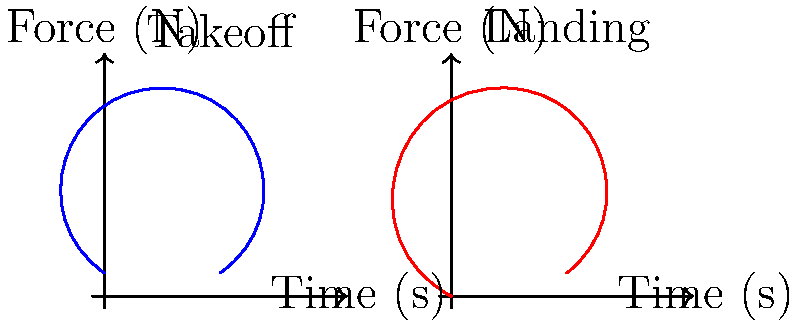As a professional figure skater, analyze the force-time graphs for the takeoff and landing phases of a toe loop jump. If the skater's mass is 55 kg, estimate the difference in vertical velocity between takeoff and landing, assuming the jump lasts 0.6 seconds. To solve this problem, we'll use the impulse-momentum relationship and the given force-time graphs. Let's break it down step-by-step:

1) The impulse-momentum theorem states that the change in momentum equals the impulse:
   $$\Delta p = F_{avg} \cdot \Delta t$$

2) The change in momentum can also be expressed as:
   $$\Delta p = m \cdot \Delta v$$

3) Equating these:
   $$m \cdot \Delta v = F_{avg} \cdot \Delta t$$

4) The average force can be estimated from the area under the force-time curve. Let's approximate:
   - Takeoff impulse: $\approx 1000 N \cdot 0.5 s = 500 N\cdot s$ (upward)
   - Landing impulse: $\approx 1200 N \cdot 0.5 s = 600 N\cdot s$ (downward)

5) Net impulse:
   $$500 - 600 = -100 N\cdot s$$

6) Using the impulse-momentum equation:
   $$55 \cdot \Delta v = -100$$
   $$\Delta v = \frac{-100}{55} \approx -1.82 m/s$$

7) This means the landing velocity is 1.82 m/s lower than the takeoff velocity.

8) Given that the jump lasts 0.6 seconds, we can use the equation:
   $$\Delta y = \frac{1}{2}g(t)^2$$
   $$\Delta y = \frac{1}{2} \cdot 9.8 \cdot (0.6)^2 \approx 1.76 m$$

9) The total change in velocity due to gravity would be:
   $$\Delta v = g \cdot t = 9.8 \cdot 0.6 = 5.88 m/s$$

10) Therefore, the difference between takeoff and landing velocities:
    $$5.88 + 1.82 = 7.7 m/s$$
Answer: 7.7 m/s 